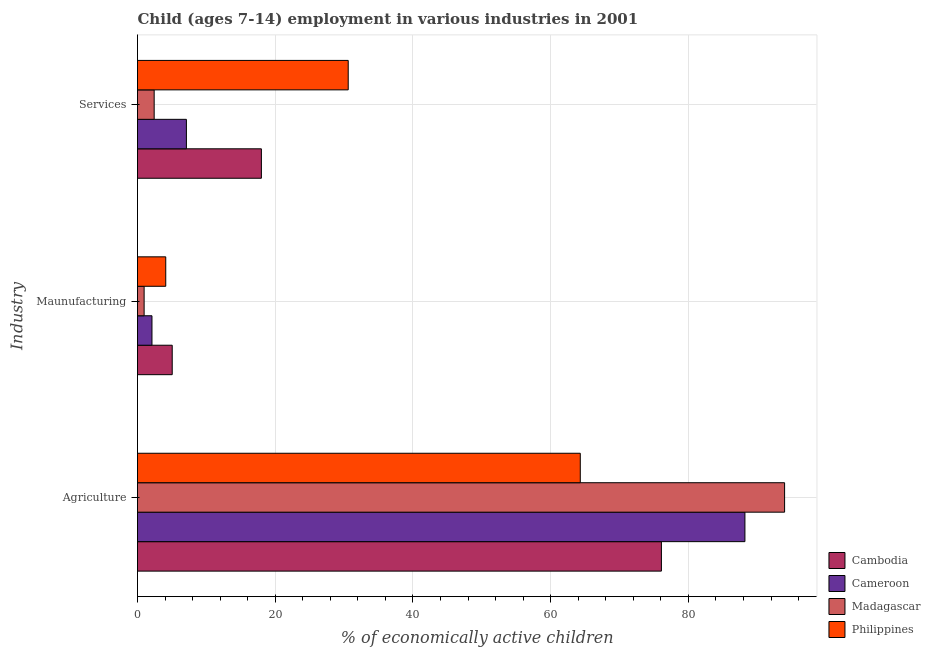How many different coloured bars are there?
Your answer should be compact. 4. How many groups of bars are there?
Ensure brevity in your answer.  3. Are the number of bars on each tick of the Y-axis equal?
Give a very brief answer. Yes. How many bars are there on the 2nd tick from the top?
Your response must be concise. 4. How many bars are there on the 3rd tick from the bottom?
Offer a very short reply. 4. What is the label of the 3rd group of bars from the top?
Offer a terse response. Agriculture. What is the percentage of economically active children in agriculture in Cambodia?
Keep it short and to the point. 76.08. Across all countries, what is the maximum percentage of economically active children in manufacturing?
Your answer should be very brief. 5.04. In which country was the percentage of economically active children in services maximum?
Your answer should be compact. Philippines. In which country was the percentage of economically active children in services minimum?
Ensure brevity in your answer.  Madagascar. What is the total percentage of economically active children in agriculture in the graph?
Your response must be concise. 322.56. What is the difference between the percentage of economically active children in services in Philippines and that in Madagascar?
Provide a short and direct response. 28.18. What is the difference between the percentage of economically active children in agriculture in Cambodia and the percentage of economically active children in services in Madagascar?
Keep it short and to the point. 73.66. What is the average percentage of economically active children in manufacturing per country?
Offer a terse response. 3.05. What is the ratio of the percentage of economically active children in services in Cambodia to that in Madagascar?
Ensure brevity in your answer.  7.43. Is the difference between the percentage of economically active children in services in Madagascar and Philippines greater than the difference between the percentage of economically active children in manufacturing in Madagascar and Philippines?
Your answer should be compact. No. What is the difference between the highest and the second highest percentage of economically active children in services?
Offer a terse response. 12.61. What is the difference between the highest and the lowest percentage of economically active children in services?
Your response must be concise. 28.18. What does the 2nd bar from the top in Agriculture represents?
Your response must be concise. Madagascar. What does the 3rd bar from the bottom in Maunufacturing represents?
Give a very brief answer. Madagascar. Are the values on the major ticks of X-axis written in scientific E-notation?
Provide a succinct answer. No. Does the graph contain grids?
Offer a very short reply. Yes. Where does the legend appear in the graph?
Make the answer very short. Bottom right. How many legend labels are there?
Provide a succinct answer. 4. How are the legend labels stacked?
Offer a terse response. Vertical. What is the title of the graph?
Provide a short and direct response. Child (ages 7-14) employment in various industries in 2001. Does "Israel" appear as one of the legend labels in the graph?
Keep it short and to the point. No. What is the label or title of the X-axis?
Provide a succinct answer. % of economically active children. What is the label or title of the Y-axis?
Your response must be concise. Industry. What is the % of economically active children of Cambodia in Agriculture?
Your response must be concise. 76.08. What is the % of economically active children in Cameroon in Agriculture?
Give a very brief answer. 88.21. What is the % of economically active children of Madagascar in Agriculture?
Your answer should be compact. 93.97. What is the % of economically active children of Philippines in Agriculture?
Keep it short and to the point. 64.3. What is the % of economically active children in Cambodia in Maunufacturing?
Your answer should be very brief. 5.04. What is the % of economically active children of Cameroon in Maunufacturing?
Your answer should be very brief. 2.1. What is the % of economically active children in Philippines in Maunufacturing?
Keep it short and to the point. 4.1. What is the % of economically active children of Cambodia in Services?
Give a very brief answer. 17.99. What is the % of economically active children of Madagascar in Services?
Give a very brief answer. 2.42. What is the % of economically active children in Philippines in Services?
Offer a terse response. 30.6. Across all Industry, what is the maximum % of economically active children in Cambodia?
Provide a short and direct response. 76.08. Across all Industry, what is the maximum % of economically active children of Cameroon?
Give a very brief answer. 88.21. Across all Industry, what is the maximum % of economically active children in Madagascar?
Your answer should be very brief. 93.97. Across all Industry, what is the maximum % of economically active children in Philippines?
Offer a terse response. 64.3. Across all Industry, what is the minimum % of economically active children of Cambodia?
Your response must be concise. 5.04. Across all Industry, what is the minimum % of economically active children of Philippines?
Give a very brief answer. 4.1. What is the total % of economically active children of Cambodia in the graph?
Ensure brevity in your answer.  99.11. What is the total % of economically active children of Cameroon in the graph?
Ensure brevity in your answer.  97.41. What is the total % of economically active children in Madagascar in the graph?
Give a very brief answer. 97.35. What is the total % of economically active children in Philippines in the graph?
Keep it short and to the point. 99. What is the difference between the % of economically active children of Cambodia in Agriculture and that in Maunufacturing?
Offer a terse response. 71.04. What is the difference between the % of economically active children of Cameroon in Agriculture and that in Maunufacturing?
Your response must be concise. 86.11. What is the difference between the % of economically active children in Madagascar in Agriculture and that in Maunufacturing?
Your answer should be compact. 93.01. What is the difference between the % of economically active children in Philippines in Agriculture and that in Maunufacturing?
Offer a terse response. 60.2. What is the difference between the % of economically active children of Cambodia in Agriculture and that in Services?
Keep it short and to the point. 58.09. What is the difference between the % of economically active children of Cameroon in Agriculture and that in Services?
Offer a terse response. 81.11. What is the difference between the % of economically active children in Madagascar in Agriculture and that in Services?
Your answer should be compact. 91.55. What is the difference between the % of economically active children in Philippines in Agriculture and that in Services?
Provide a short and direct response. 33.7. What is the difference between the % of economically active children of Cambodia in Maunufacturing and that in Services?
Your answer should be compact. -12.95. What is the difference between the % of economically active children of Madagascar in Maunufacturing and that in Services?
Keep it short and to the point. -1.46. What is the difference between the % of economically active children of Philippines in Maunufacturing and that in Services?
Offer a terse response. -26.5. What is the difference between the % of economically active children of Cambodia in Agriculture and the % of economically active children of Cameroon in Maunufacturing?
Give a very brief answer. 73.98. What is the difference between the % of economically active children in Cambodia in Agriculture and the % of economically active children in Madagascar in Maunufacturing?
Keep it short and to the point. 75.12. What is the difference between the % of economically active children of Cambodia in Agriculture and the % of economically active children of Philippines in Maunufacturing?
Your answer should be very brief. 71.98. What is the difference between the % of economically active children in Cameroon in Agriculture and the % of economically active children in Madagascar in Maunufacturing?
Offer a very short reply. 87.25. What is the difference between the % of economically active children of Cameroon in Agriculture and the % of economically active children of Philippines in Maunufacturing?
Offer a terse response. 84.11. What is the difference between the % of economically active children in Madagascar in Agriculture and the % of economically active children in Philippines in Maunufacturing?
Make the answer very short. 89.87. What is the difference between the % of economically active children in Cambodia in Agriculture and the % of economically active children in Cameroon in Services?
Give a very brief answer. 68.98. What is the difference between the % of economically active children in Cambodia in Agriculture and the % of economically active children in Madagascar in Services?
Your answer should be compact. 73.66. What is the difference between the % of economically active children of Cambodia in Agriculture and the % of economically active children of Philippines in Services?
Make the answer very short. 45.48. What is the difference between the % of economically active children in Cameroon in Agriculture and the % of economically active children in Madagascar in Services?
Give a very brief answer. 85.79. What is the difference between the % of economically active children of Cameroon in Agriculture and the % of economically active children of Philippines in Services?
Your answer should be very brief. 57.61. What is the difference between the % of economically active children of Madagascar in Agriculture and the % of economically active children of Philippines in Services?
Ensure brevity in your answer.  63.37. What is the difference between the % of economically active children in Cambodia in Maunufacturing and the % of economically active children in Cameroon in Services?
Provide a succinct answer. -2.06. What is the difference between the % of economically active children of Cambodia in Maunufacturing and the % of economically active children of Madagascar in Services?
Give a very brief answer. 2.62. What is the difference between the % of economically active children in Cambodia in Maunufacturing and the % of economically active children in Philippines in Services?
Offer a very short reply. -25.56. What is the difference between the % of economically active children in Cameroon in Maunufacturing and the % of economically active children in Madagascar in Services?
Provide a short and direct response. -0.32. What is the difference between the % of economically active children in Cameroon in Maunufacturing and the % of economically active children in Philippines in Services?
Your answer should be very brief. -28.5. What is the difference between the % of economically active children of Madagascar in Maunufacturing and the % of economically active children of Philippines in Services?
Provide a succinct answer. -29.64. What is the average % of economically active children in Cambodia per Industry?
Provide a succinct answer. 33.04. What is the average % of economically active children of Cameroon per Industry?
Keep it short and to the point. 32.47. What is the average % of economically active children in Madagascar per Industry?
Make the answer very short. 32.45. What is the average % of economically active children in Philippines per Industry?
Your response must be concise. 33. What is the difference between the % of economically active children of Cambodia and % of economically active children of Cameroon in Agriculture?
Provide a succinct answer. -12.13. What is the difference between the % of economically active children in Cambodia and % of economically active children in Madagascar in Agriculture?
Offer a very short reply. -17.89. What is the difference between the % of economically active children in Cambodia and % of economically active children in Philippines in Agriculture?
Your answer should be very brief. 11.78. What is the difference between the % of economically active children of Cameroon and % of economically active children of Madagascar in Agriculture?
Provide a succinct answer. -5.76. What is the difference between the % of economically active children of Cameroon and % of economically active children of Philippines in Agriculture?
Keep it short and to the point. 23.91. What is the difference between the % of economically active children in Madagascar and % of economically active children in Philippines in Agriculture?
Your answer should be very brief. 29.67. What is the difference between the % of economically active children of Cambodia and % of economically active children of Cameroon in Maunufacturing?
Your answer should be very brief. 2.94. What is the difference between the % of economically active children in Cambodia and % of economically active children in Madagascar in Maunufacturing?
Your answer should be compact. 4.08. What is the difference between the % of economically active children in Cambodia and % of economically active children in Philippines in Maunufacturing?
Your answer should be very brief. 0.94. What is the difference between the % of economically active children of Cameroon and % of economically active children of Madagascar in Maunufacturing?
Give a very brief answer. 1.14. What is the difference between the % of economically active children in Madagascar and % of economically active children in Philippines in Maunufacturing?
Your answer should be very brief. -3.14. What is the difference between the % of economically active children of Cambodia and % of economically active children of Cameroon in Services?
Ensure brevity in your answer.  10.89. What is the difference between the % of economically active children of Cambodia and % of economically active children of Madagascar in Services?
Give a very brief answer. 15.57. What is the difference between the % of economically active children in Cambodia and % of economically active children in Philippines in Services?
Provide a succinct answer. -12.61. What is the difference between the % of economically active children of Cameroon and % of economically active children of Madagascar in Services?
Ensure brevity in your answer.  4.68. What is the difference between the % of economically active children of Cameroon and % of economically active children of Philippines in Services?
Offer a terse response. -23.5. What is the difference between the % of economically active children of Madagascar and % of economically active children of Philippines in Services?
Make the answer very short. -28.18. What is the ratio of the % of economically active children of Cambodia in Agriculture to that in Maunufacturing?
Keep it short and to the point. 15.1. What is the ratio of the % of economically active children in Cameroon in Agriculture to that in Maunufacturing?
Offer a very short reply. 42. What is the ratio of the % of economically active children of Madagascar in Agriculture to that in Maunufacturing?
Ensure brevity in your answer.  97.89. What is the ratio of the % of economically active children in Philippines in Agriculture to that in Maunufacturing?
Provide a short and direct response. 15.68. What is the ratio of the % of economically active children of Cambodia in Agriculture to that in Services?
Make the answer very short. 4.23. What is the ratio of the % of economically active children of Cameroon in Agriculture to that in Services?
Provide a succinct answer. 12.42. What is the ratio of the % of economically active children of Madagascar in Agriculture to that in Services?
Keep it short and to the point. 38.83. What is the ratio of the % of economically active children of Philippines in Agriculture to that in Services?
Provide a short and direct response. 2.1. What is the ratio of the % of economically active children in Cambodia in Maunufacturing to that in Services?
Keep it short and to the point. 0.28. What is the ratio of the % of economically active children in Cameroon in Maunufacturing to that in Services?
Give a very brief answer. 0.3. What is the ratio of the % of economically active children of Madagascar in Maunufacturing to that in Services?
Give a very brief answer. 0.4. What is the ratio of the % of economically active children of Philippines in Maunufacturing to that in Services?
Offer a terse response. 0.13. What is the difference between the highest and the second highest % of economically active children in Cambodia?
Offer a terse response. 58.09. What is the difference between the highest and the second highest % of economically active children in Cameroon?
Provide a short and direct response. 81.11. What is the difference between the highest and the second highest % of economically active children in Madagascar?
Ensure brevity in your answer.  91.55. What is the difference between the highest and the second highest % of economically active children of Philippines?
Your answer should be very brief. 33.7. What is the difference between the highest and the lowest % of economically active children of Cambodia?
Your answer should be very brief. 71.04. What is the difference between the highest and the lowest % of economically active children in Cameroon?
Give a very brief answer. 86.11. What is the difference between the highest and the lowest % of economically active children in Madagascar?
Offer a terse response. 93.01. What is the difference between the highest and the lowest % of economically active children in Philippines?
Provide a succinct answer. 60.2. 